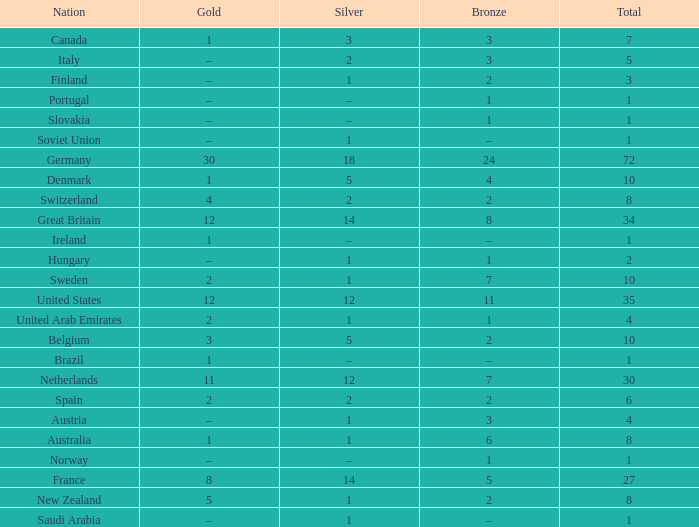What is the total number of Total, when Silver is 1, and when Bronze is 7? 1.0. Could you help me parse every detail presented in this table? {'header': ['Nation', 'Gold', 'Silver', 'Bronze', 'Total'], 'rows': [['Canada', '1', '3', '3', '7'], ['Italy', '–', '2', '3', '5'], ['Finland', '–', '1', '2', '3'], ['Portugal', '–', '–', '1', '1'], ['Slovakia', '–', '–', '1', '1'], ['Soviet Union', '–', '1', '–', '1'], ['Germany', '30', '18', '24', '72'], ['Denmark', '1', '5', '4', '10'], ['Switzerland', '4', '2', '2', '8'], ['Great Britain', '12', '14', '8', '34'], ['Ireland', '1', '–', '–', '1'], ['Hungary', '–', '1', '1', '2'], ['Sweden', '2', '1', '7', '10'], ['United States', '12', '12', '11', '35'], ['United Arab Emirates', '2', '1', '1', '4'], ['Belgium', '3', '5', '2', '10'], ['Brazil', '1', '–', '–', '1'], ['Netherlands', '11', '12', '7', '30'], ['Spain', '2', '2', '2', '6'], ['Austria', '–', '1', '3', '4'], ['Australia', '1', '1', '6', '8'], ['Norway', '–', '–', '1', '1'], ['France', '8', '14', '5', '27'], ['New Zealand', '5', '1', '2', '8'], ['Saudi Arabia', '–', '1', '–', '1']]} 